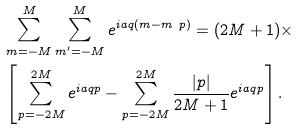Convert formula to latex. <formula><loc_0><loc_0><loc_500><loc_500>\ & \sum _ { m = - M } ^ { M } \sum _ { m ^ { \prime } = - M } ^ { M } e ^ { i a q ( m - m \ p ) } = ( 2 M + 1 ) \times \\ \ & \left [ \sum _ { p = - 2 M } ^ { 2 M } e ^ { i a q p } - \sum _ { p = - 2 M } ^ { 2 M } { \frac { | p | } { 2 M + 1 } } e ^ { i a q p } \right ] .</formula> 